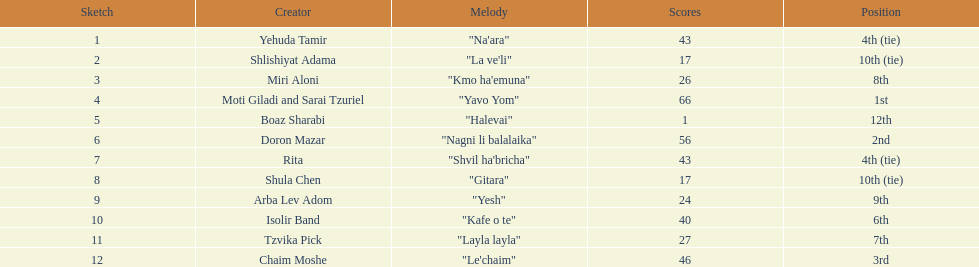What are the number of times an artist earned first place? 1. 